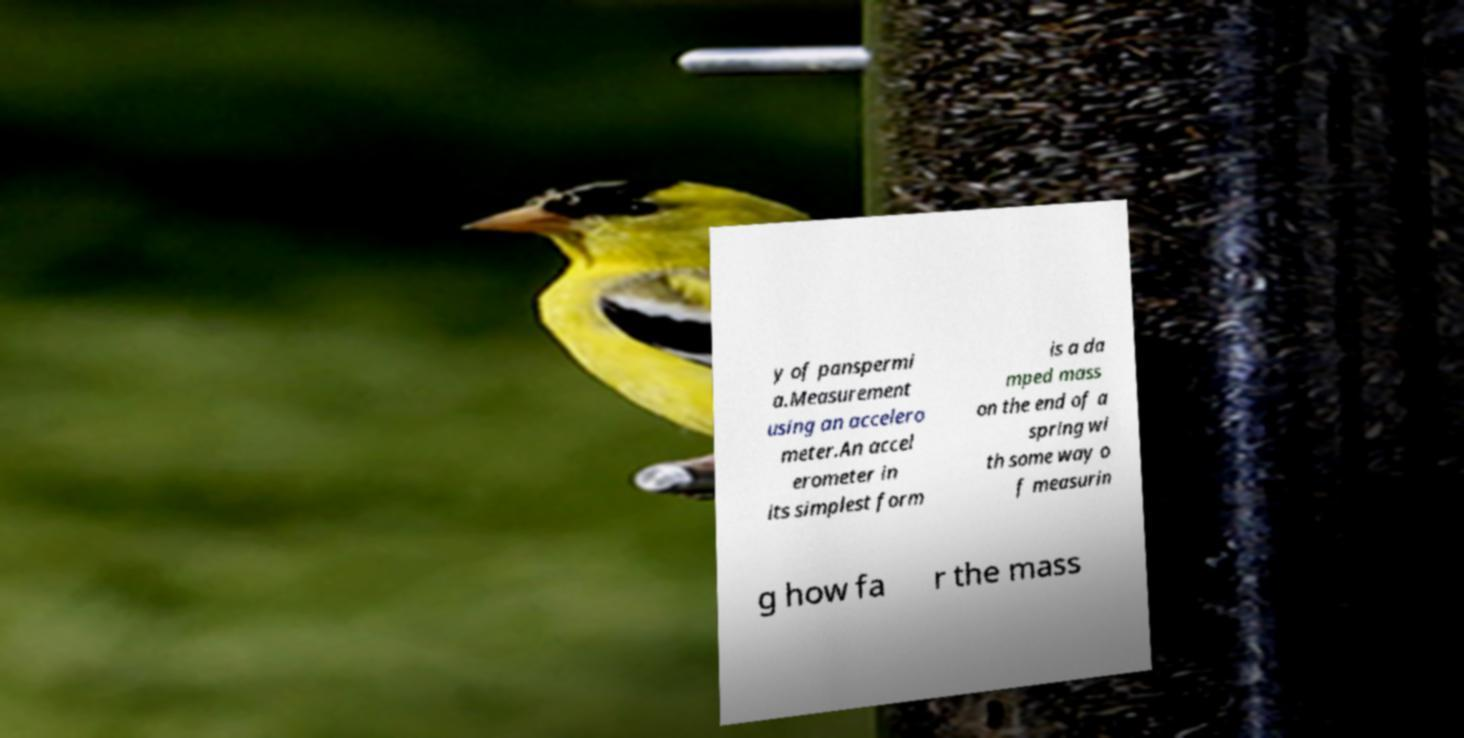Can you read and provide the text displayed in the image?This photo seems to have some interesting text. Can you extract and type it out for me? y of panspermi a.Measurement using an accelero meter.An accel erometer in its simplest form is a da mped mass on the end of a spring wi th some way o f measurin g how fa r the mass 